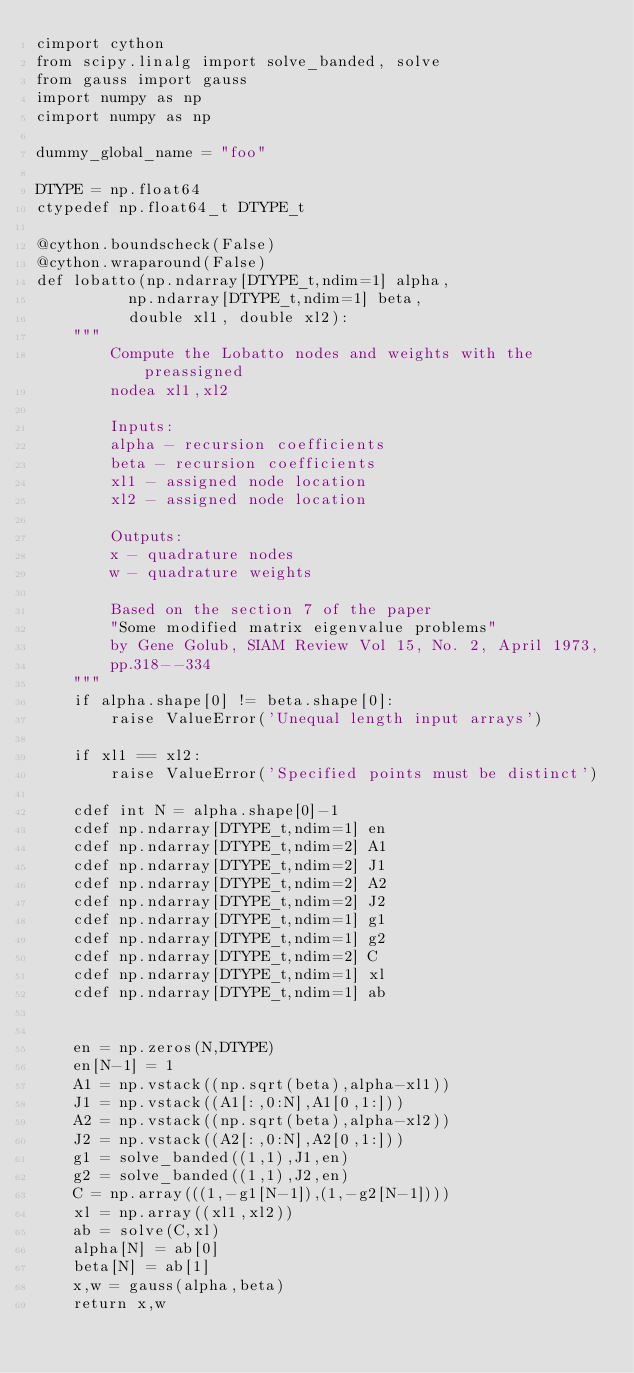Convert code to text. <code><loc_0><loc_0><loc_500><loc_500><_Cython_>cimport cython
from scipy.linalg import solve_banded, solve
from gauss import gauss
import numpy as np
cimport numpy as np

dummy_global_name = "foo"

DTYPE = np.float64
ctypedef np.float64_t DTYPE_t

@cython.boundscheck(False)
@cython.wraparound(False)
def lobatto(np.ndarray[DTYPE_t,ndim=1] alpha,
          np.ndarray[DTYPE_t,ndim=1] beta,
          double xl1, double xl2):
    """
        Compute the Lobatto nodes and weights with the preassigned 
        nodea xl1,xl2
        
        Inputs: 
        alpha - recursion coefficients
        beta - recursion coefficients
        xl1 - assigned node location
        xl2 - assigned node location

        Outputs: 
        x - quadrature nodes        
        w - quadrature weights
   
        Based on the section 7 of the paper 
        "Some modified matrix eigenvalue problems" 
        by Gene Golub, SIAM Review Vol 15, No. 2, April 1973, 
        pp.318--334
    """
    if alpha.shape[0] != beta.shape[0]:
        raise ValueError('Unequal length input arrays')    
 
    if xl1 == xl2:
        raise ValueError('Specified points must be distinct')
 
    cdef int N = alpha.shape[0]-1
    cdef np.ndarray[DTYPE_t,ndim=1] en
    cdef np.ndarray[DTYPE_t,ndim=2] A1
    cdef np.ndarray[DTYPE_t,ndim=2] J1
    cdef np.ndarray[DTYPE_t,ndim=2] A2 
    cdef np.ndarray[DTYPE_t,ndim=2] J2
    cdef np.ndarray[DTYPE_t,ndim=1] g1
    cdef np.ndarray[DTYPE_t,ndim=1] g2
    cdef np.ndarray[DTYPE_t,ndim=2] C
    cdef np.ndarray[DTYPE_t,ndim=1] xl 
    cdef np.ndarray[DTYPE_t,ndim=1] ab


    en = np.zeros(N,DTYPE)
    en[N-1] = 1
    A1 = np.vstack((np.sqrt(beta),alpha-xl1))
    J1 = np.vstack((A1[:,0:N],A1[0,1:]))
    A2 = np.vstack((np.sqrt(beta),alpha-xl2))
    J2 = np.vstack((A2[:,0:N],A2[0,1:]))
    g1 = solve_banded((1,1),J1,en)
    g2 = solve_banded((1,1),J2,en)
    C = np.array(((1,-g1[N-1]),(1,-g2[N-1])))
    xl = np.array((xl1,xl2))  
    ab = solve(C,xl)
    alpha[N] = ab[0]
    beta[N] = ab[1]
    x,w = gauss(alpha,beta)
    return x,w


</code> 